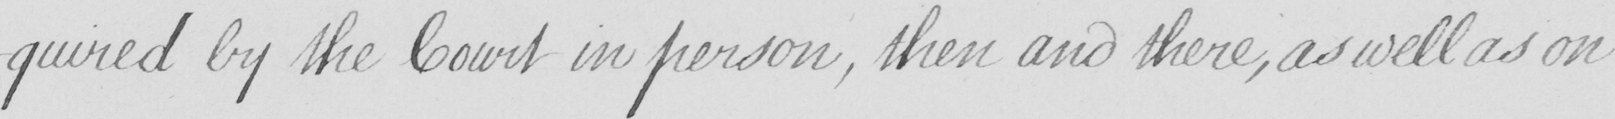Transcribe the text shown in this historical manuscript line. -quired by the Court in person , then and there , as well as on 